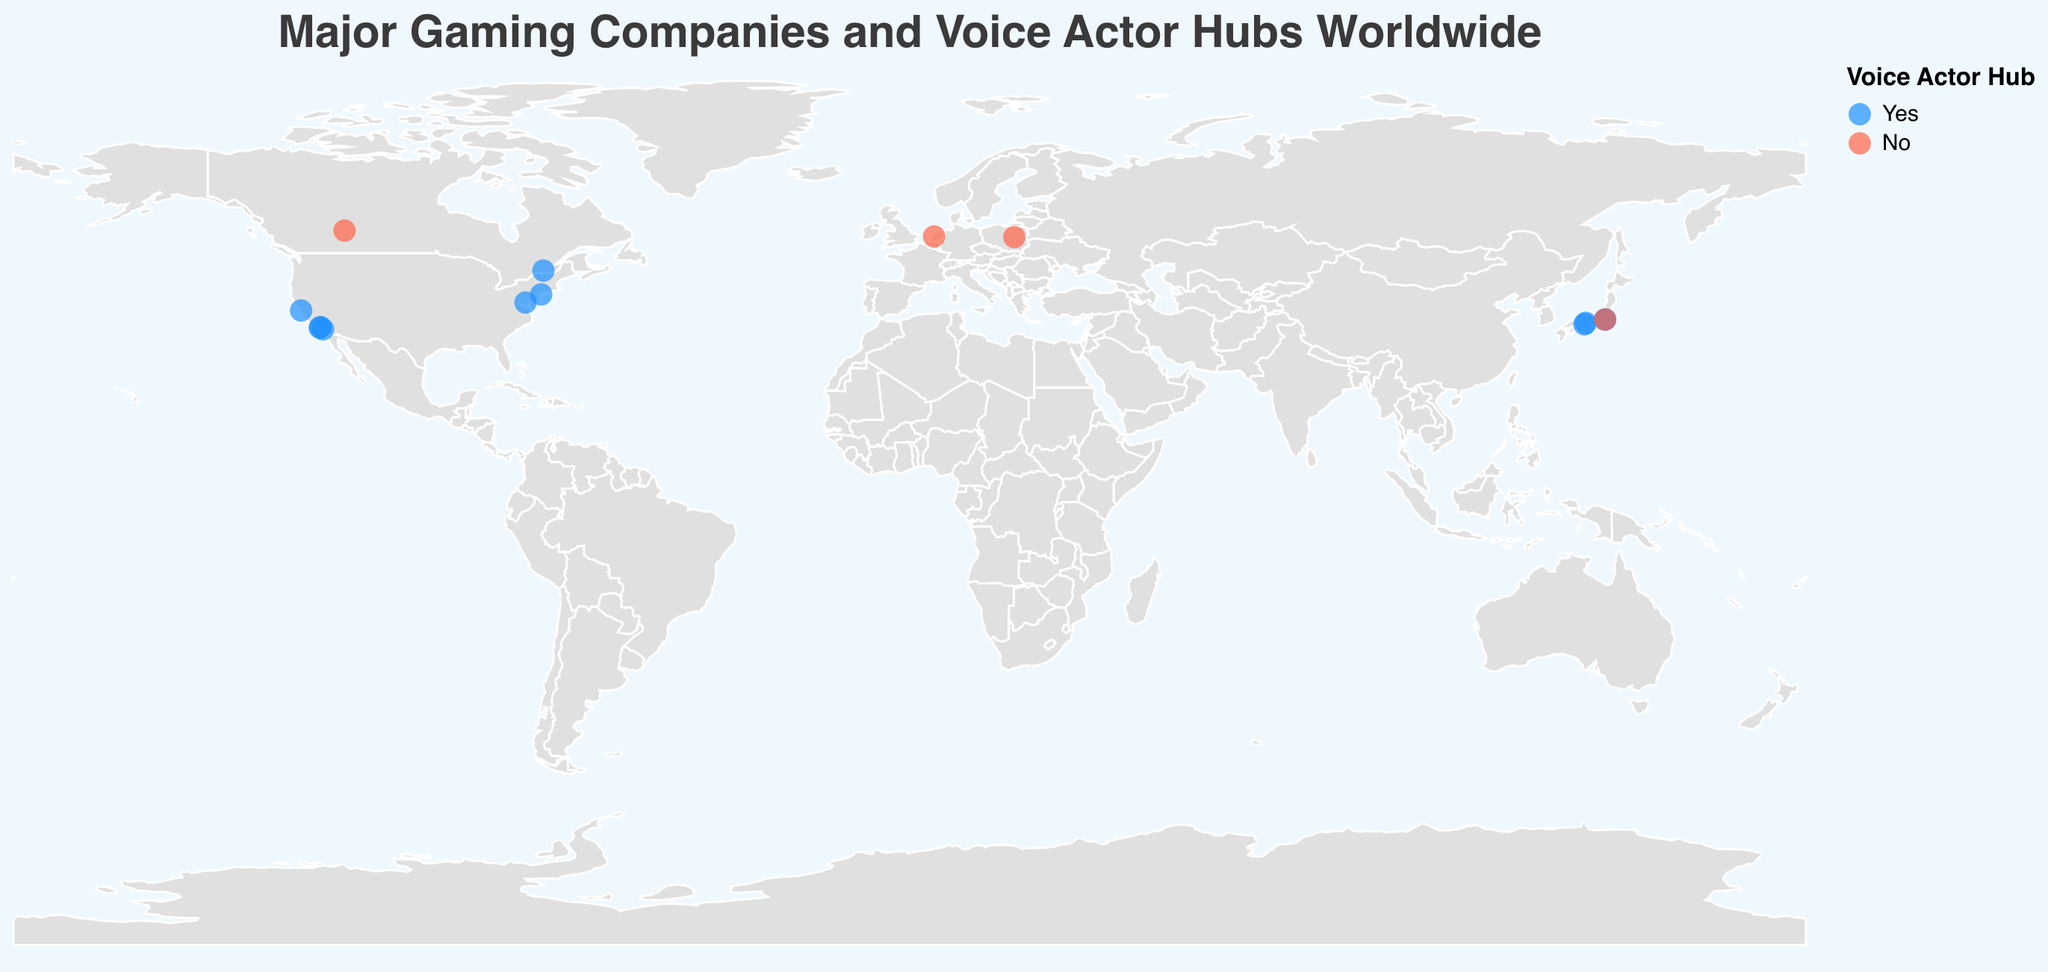Where is Nintendo located and is it a voice actor hub? Nintendo is located in Kyoto, Japan. The color and legend indicate that it is a voice actor hub.
Answer: Kyoto, Japan, Yes How many voice actor hubs are there in the USA? By looking at the points colored as voice actor hubs (blue) located in the USA, we find Redwood City, New York City, Irvine, Santa Monica, Rockville, and Burbank. Counting these, there are six voice actor hubs in the USA.
Answer: 6 Which companies in Japan are not located in a voice actor hub? By checking Japan's locations in the figure, Kojima Productions in Tokyo is marked in a different color (red), indicating it is not a voice actor hub.
Answer: Kojima Productions Compare the number of gaming companies in Japan and the USA. Which country has more? The figure shows Nintendo (Kyoto), Square Enix (Tokyo), SEGA (Tokyo), Capcom (Osaka), and Kojima Productions (Tokyo) in Japan—five companies. In the USA, Electronic Arts (Redwood City), Rockstar Games (New York City), Blizzard Entertainment (Irvine), Naughty Dog (Santa Monica), Bethesda Game Studios (Rockville), and Insomniac Games (Burbank) are located—six companies. Thus, the USA has more gaming companies.
Answer: USA What percentage of Canadian gaming companies are not in voice actor hubs? In Canada, there are Ubisoft (Montreal) and BioWare (Edmonton). Among these, only BioWare (Edmonton) is not a voice actor hub. Therefore, 50% of the Canadian gaming companies are not in voice actor hubs.
Answer: 50% Which city in Japan hosts the most gaming companies? Tokyo hosts Square Enix, SEGA, and Kojima Productions, making it the city with the most gaming companies in Japan.
Answer: Tokyo Determine the average latitude of the gaming companies in Europe. The European cities listed are Warsaw (CD Projekt Red) and Amsterdam (Guerrilla Games), with latitudes 52.2297 and 52.3676 respectively. The average latitude is (52.2297 + 52.3676) / 2 which equals approximately 52.29865.
Answer: 52.29865 Identify the company closest to the equator and state if it is a voice actor hub. The closest city to the equator among the listed is Irvine, USA, with a latitude of 33.6846 (Blizzard Entertainment). It is marked as a voice actor hub.
Answer: Blizzard Entertainment, Yes 